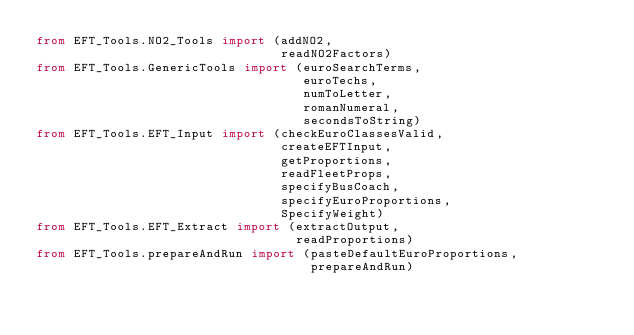Convert code to text. <code><loc_0><loc_0><loc_500><loc_500><_Python_>from EFT_Tools.NO2_Tools import (addNO2,
                                 readNO2Factors)
from EFT_Tools.GenericTools import (euroSearchTerms,
                                    euroTechs,
                                    numToLetter,
                                    romanNumeral,
                                    secondsToString)
from EFT_Tools.EFT_Input import (checkEuroClassesValid,
                                 createEFTInput,
                                 getProportions,
                                 readFleetProps,
                                 specifyBusCoach,
                                 specifyEuroProportions,
                                 SpecifyWeight)
from EFT_Tools.EFT_Extract import (extractOutput,
                                   readProportions)
from EFT_Tools.prepareAndRun import (pasteDefaultEuroProportions,
                                     prepareAndRun)</code> 